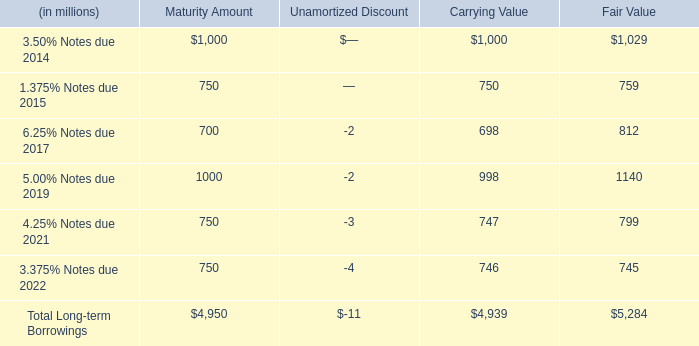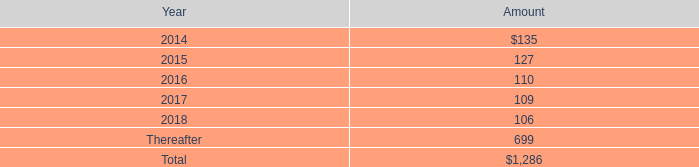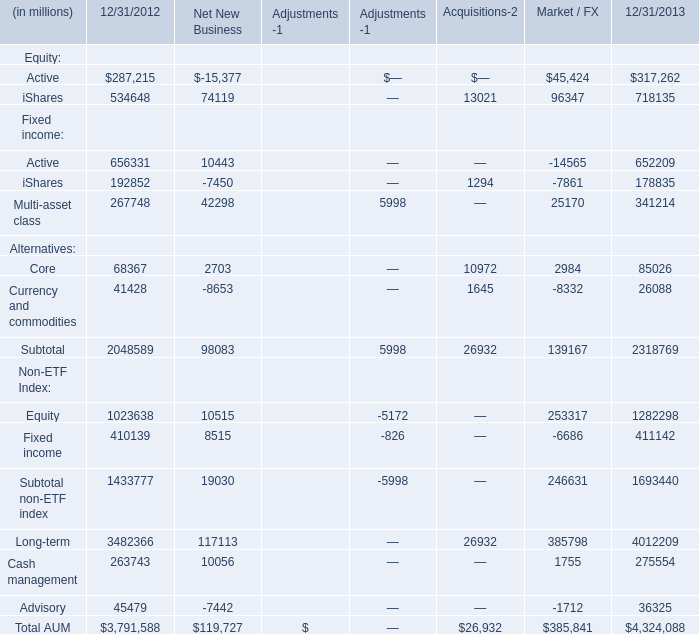The total amount of which section ranks first for 12/31/2012? 
Answer: Total AUM. 